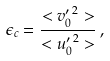Convert formula to latex. <formula><loc_0><loc_0><loc_500><loc_500>\epsilon _ { c } = \frac { < { v _ { 0 } ^ { \prime } } ^ { 2 } > } { < { u _ { 0 } ^ { \prime } } ^ { 2 } > } \, ,</formula> 